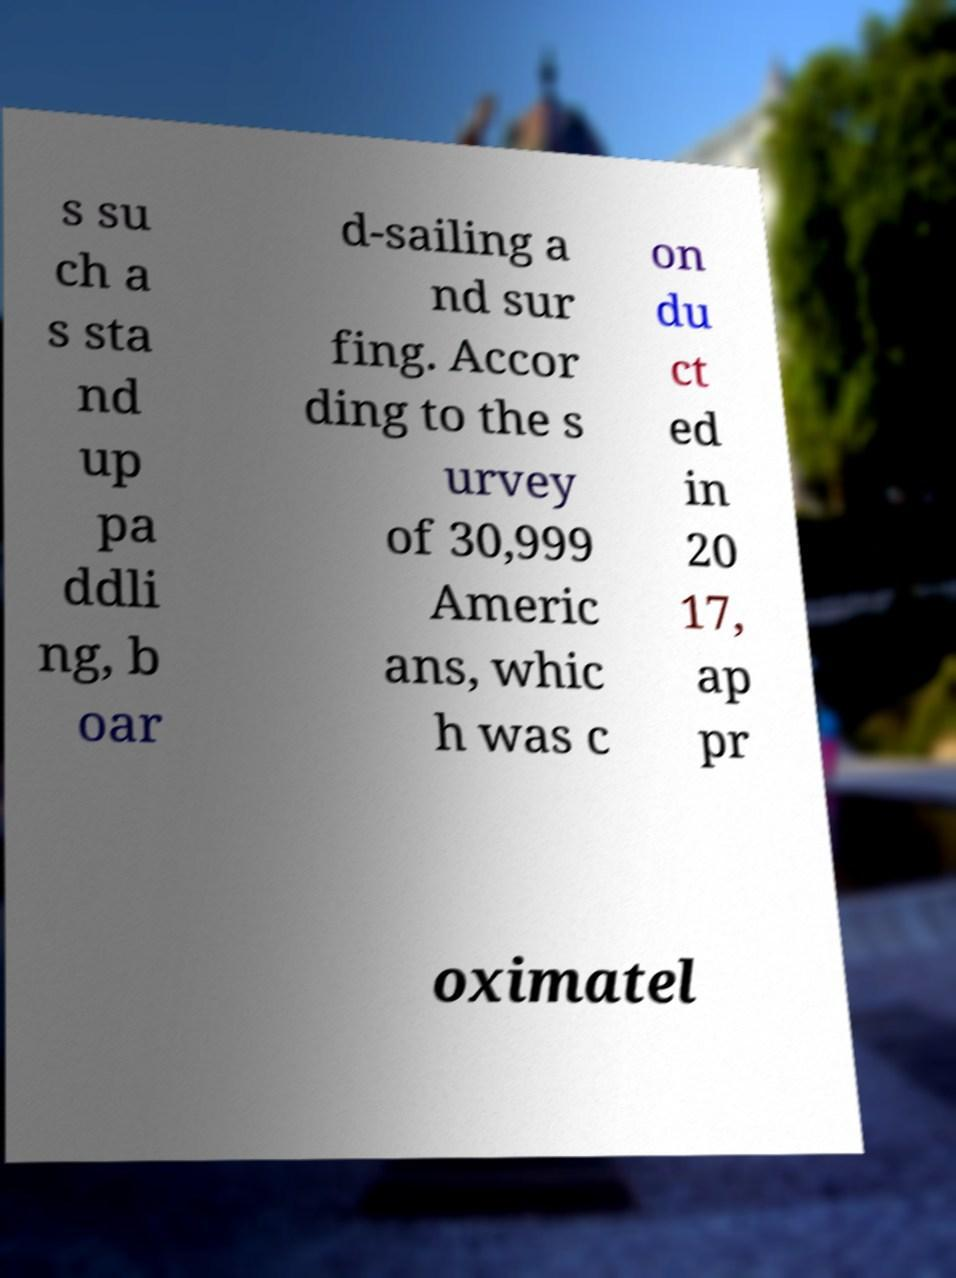Can you accurately transcribe the text from the provided image for me? s su ch a s sta nd up pa ddli ng, b oar d-sailing a nd sur fing. Accor ding to the s urvey of 30,999 Americ ans, whic h was c on du ct ed in 20 17, ap pr oximatel 